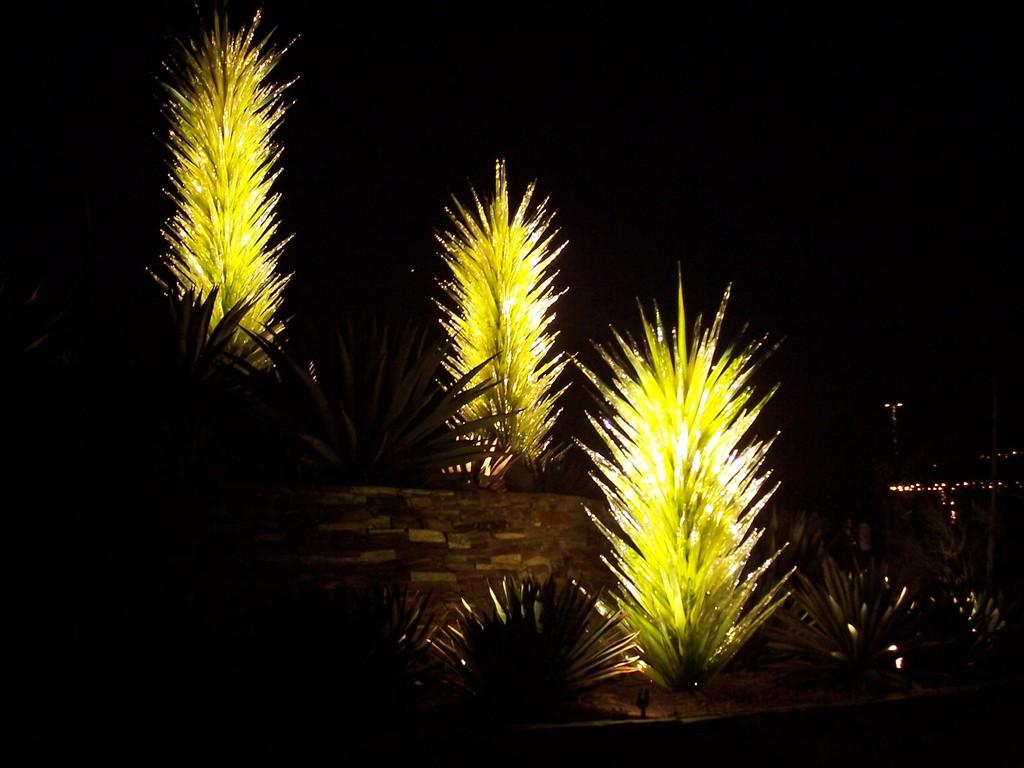What type of natural elements can be seen in the image? There are trees in the image. What man-made structure is present in the image? There is a wall in the image. What type of artificial light sources are visible in the image? There are lights in the image. How would you describe the overall lighting in the image? The background of the image is dark. What type of liquid can be seen flowing down the wall in the image? There is no liquid flowing down the wall in the image; it only shows trees, a wall, lights, and a dark background. How many kittens are playing among the trees in the image? There are no kittens present in the image; it only shows trees, a wall, lights, and a dark background. 